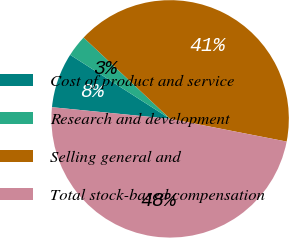Convert chart. <chart><loc_0><loc_0><loc_500><loc_500><pie_chart><fcel>Cost of product and service<fcel>Research and development<fcel>Selling general and<fcel>Total stock-based compensation<nl><fcel>7.5%<fcel>2.94%<fcel>41.06%<fcel>48.5%<nl></chart> 